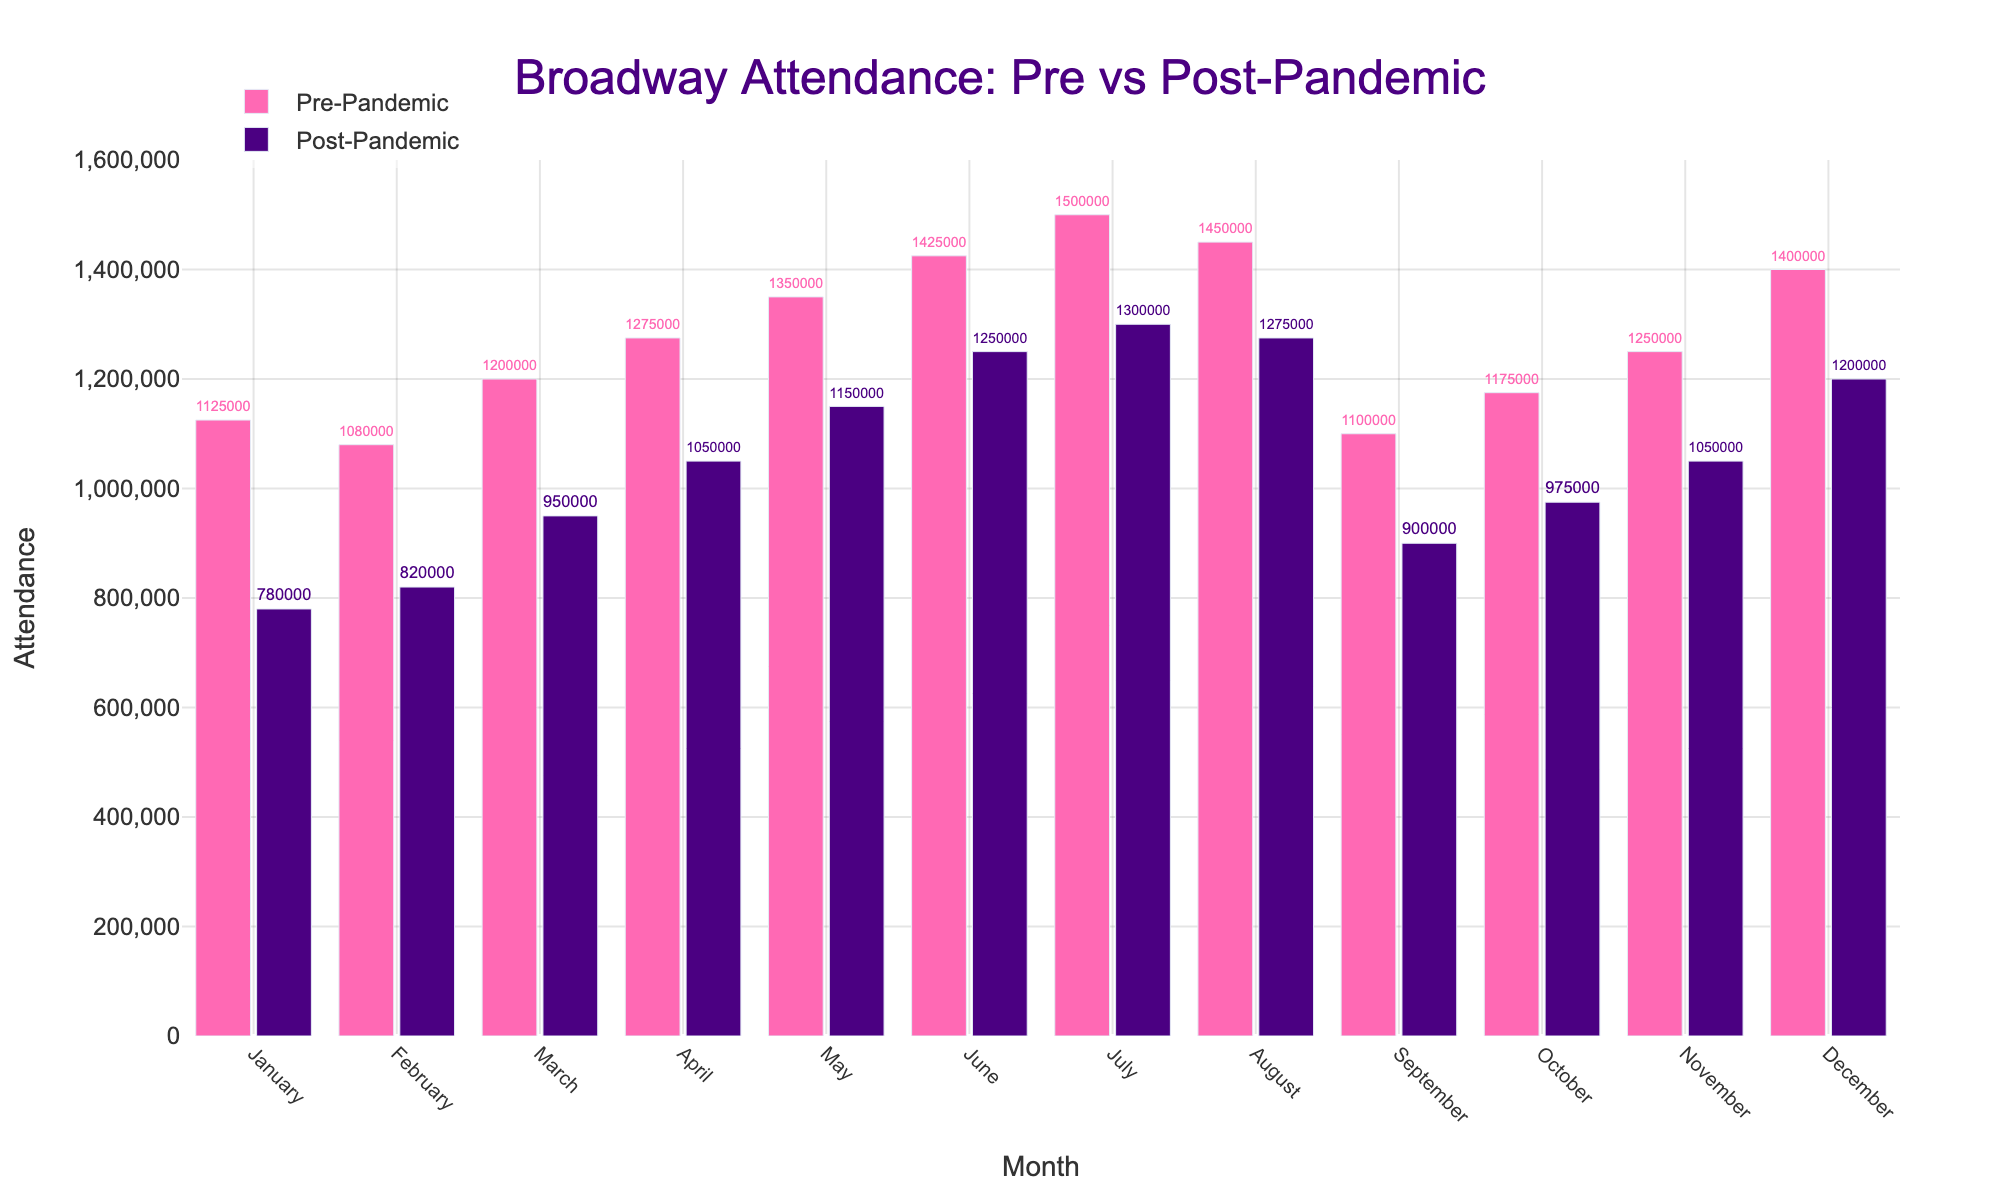What's the largest difference in attendance between pre-pandemic and post-pandemic for any month? To find the largest difference, we calculate the difference for each month and find the highest value: January (1125000 - 780000 = 345000), February (1080000 - 820000 = 260000), March (1200000 - 950000 = 250000), April (1275000 - 1050000 = 225000), May (1350000 - 1150000 = 200000), June (1425000 - 1250000 = 175000), July (1500000 - 1300000 = 200000), August (1450000 - 1275000 = 175000), September (1100000 - 900000 = 200000), October (1175000 - 975000 = 200000), November (1250000 - 1050000 = 200000), December (1400000 - 1200000 = 200000). The largest difference is 345000 in January.
Answer: 345000 Which month had the highest attendance in the pre-pandemic season? By looking at the heights of the bars in the pre-pandemic category, the month with the highest attendance is July with 1500000.
Answer: July Which month had the smallest difference in attendance between pre-pandemic and post-pandemic? We calculate the difference for each month and find the smallest value: January (345000), February (260000), March (250000), April (225000), May (200000), June (175000), July (200000), August (175000), September (200000), October (200000), November (200000), December (200000). The smallest difference is 175000 in June and August.
Answer: June and August What is the average post-pandemic attendance for the months of June, July, and August? To find the average, we sum the attendance for these months and divide by the number of months: (1250000 + 1300000 + 1275000) / 3 = 3825000 / 3 = 1275000.
Answer: 1275000 During which months did post-pandemic attendance surpass 1,000,000? By examining the heights of the bars in the post-pandemic category, the months with attendance greater than 1,000,000 are April, May, June, July, August, November, and December.
Answer: April, May, June, July, August, November, December What's the total pre-pandemic attendance for the year? To find the total, we sum all the pre-pandemic values: 1125000 + 1080000 + 1200000 + 1275000 + 1350000 + 1425000 + 1500000 + 1450000 + 1100000 + 1175000 + 1250000 + 1400000 = 16300000.
Answer: 16300000 By how much did attendance in December drop post-pandemic compared to June? Calculate the difference in attendance for December and June post-pandemic: June (1250000), December (1200000), difference: 1250000 - 1200000 = 50000.
Answer: 50000 Which month shows the closest post-pandemic attendance to 1,000,000? By looking at the numbers on the post-pandemic bars, October has an attendance of 975000, which is closest to 1,000,000.
Answer: October 